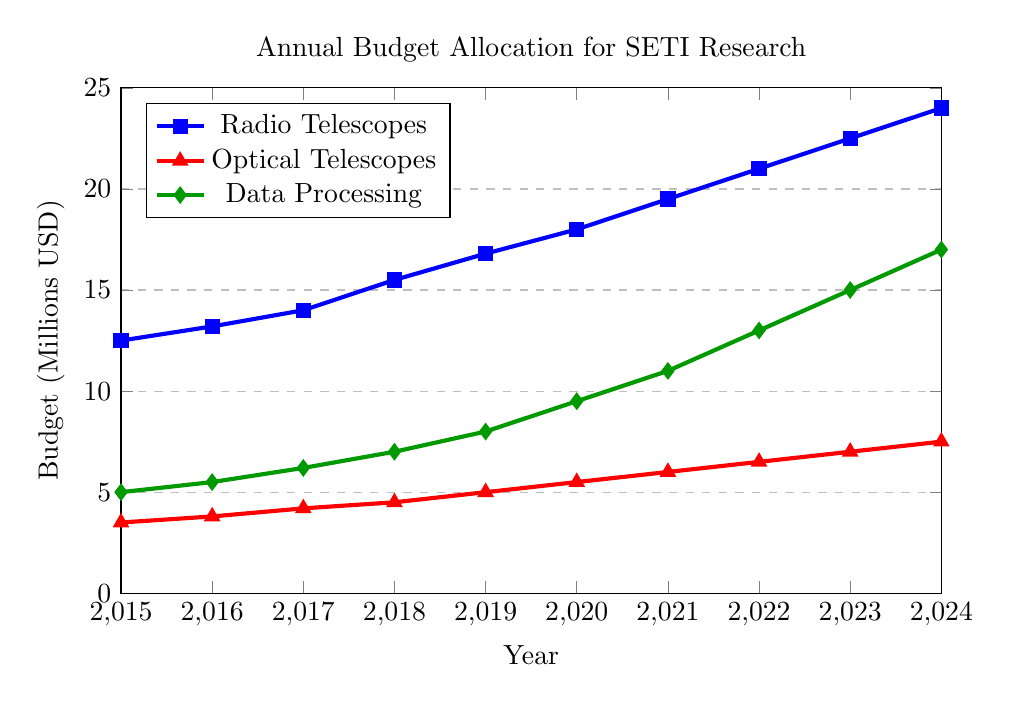What's the total budget allocation for all three areas in 2017? Sum the budgets for Radio Telescopes, Optical Telescopes, and Data Processing for the year 2017: 14 million + 4.2 million + 6.2 million = 24.4 million USD
Answer: 24.4 million USD Which technological area saw the highest budget increase from 2019 to 2020? Calculate the budget increase for each area between 2019 and 2020. Radio Telescopes increased from 16.8 million to 18 million (1.2 million). Optical Telescopes increased from 5 million to 5.5 million (0.5 million). Data Processing increased from 8 million to 9.5 million (1.5 million). The highest increase is in Data Processing.
Answer: Data Processing What is the average annual budget for Optical Telescopes from 2015 to 2024? Sum the annual budgets for Optical Telescopes over the specified years and divide by the number of years. (3.5 + 3.8 + 4.2 + 4.5 + 5 + 5.5 + 6 + 6.5 + 7 + 7.5) million = 53.5 million; Average = 53.5 million / 10 = 5.35 million USD.
Answer: 5.35 million USD How does the budget for Data Processing in 2024 compare to the budget for Radio Telescopes in 2018? Compare the budget for Data Processing in 2024 (17 million) with the budget for Radio Telescopes in 2018 (15.5 million). 17 million is greater than 15.5 million.
Answer: Greater What is the percentage increase in the budget for Radio Telescopes from 2015 to 2024? Calculate the percentage increase from 2015 (12.5 million) to 2024 (24 million): ((24 - 12.5) / 12.5) * 100 = 92%
Answer: 92% In which year did the budget for Optical Telescopes first exceed 5 million USD? Observe the budget values for Optical Telescopes over the years. In 2019, the budget for Optical Telescopes was 5 million USD, and in 2020 it increased to 5.5 million USD, so the first year it exceeded 5 million USD was 2020.
Answer: 2020 What is the overall budget trend for Data Processing over the years? The budget for Data Processing increases every year from 2015 to 2024, indicating a consistently upward trend.
Answer: Upward trend If the budget for Optical Telescopes in 2024 were to be reduced by 10%, what would it be? Calculate 10% of the Optical Telescopes budget in 2024 (7.5 million): 7.5 million * 0.1 = 0.75 million. Subtract this from 7.5 million, giving 7.5 million - 0.75 million = 6.75 million USD.
Answer: 6.75 million USD 